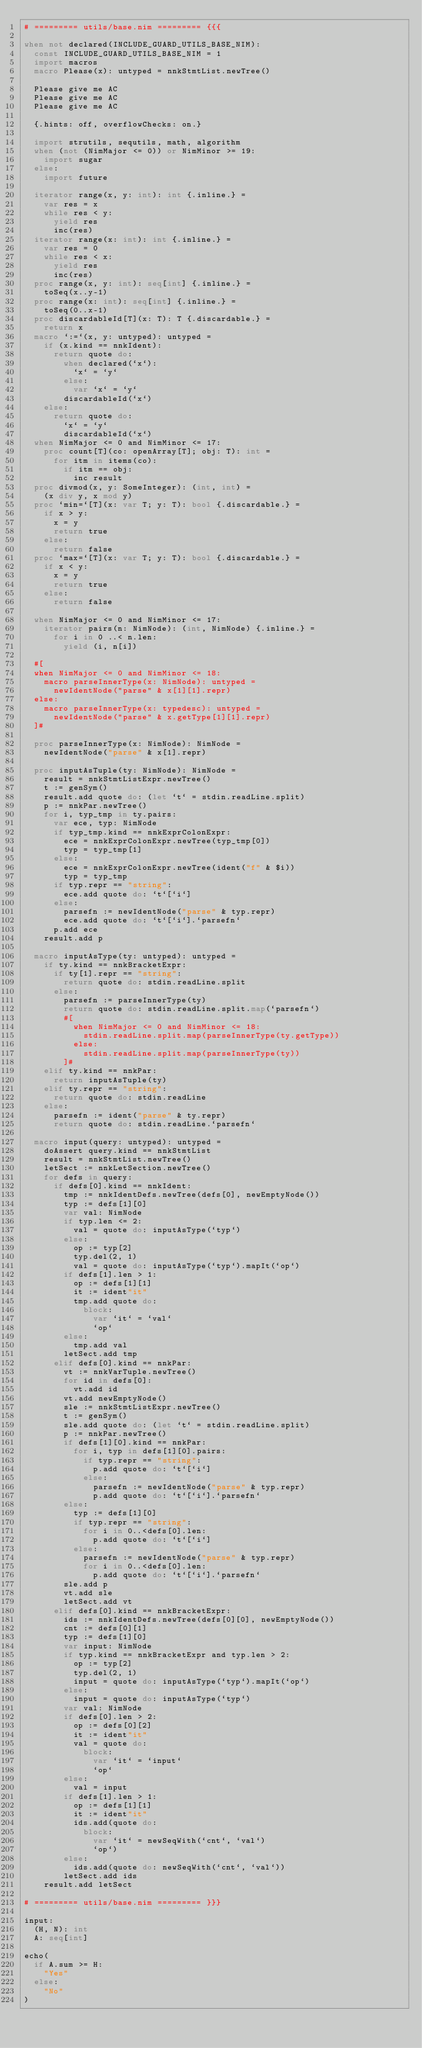Convert code to text. <code><loc_0><loc_0><loc_500><loc_500><_Nim_># ========= utils/base.nim ========= {{{

when not declared(INCLUDE_GUARD_UTILS_BASE_NIM):
  const INCLUDE_GUARD_UTILS_BASE_NIM = 1
  import macros
  macro Please(x): untyped = nnkStmtList.newTree()

  Please give me AC
  Please give me AC
  Please give me AC

  {.hints: off, overflowChecks: on.}

  import strutils, sequtils, math, algorithm
  when (not (NimMajor <= 0)) or NimMinor >= 19:
    import sugar
  else:
    import future

  iterator range(x, y: int): int {.inline.} =
    var res = x
    while res < y:
      yield res
      inc(res)
  iterator range(x: int): int {.inline.} =
    var res = 0
    while res < x:
      yield res
      inc(res)
  proc range(x, y: int): seq[int] {.inline.} =
    toSeq(x..y-1)
  proc range(x: int): seq[int] {.inline.} =
    toSeq(0..x-1)
  proc discardableId[T](x: T): T {.discardable.} =
    return x
  macro `:=`(x, y: untyped): untyped =
    if (x.kind == nnkIdent):
      return quote do:
        when declared(`x`):
          `x` = `y`
        else:
          var `x` = `y`
        discardableId(`x`)
    else:
      return quote do:
        `x` = `y`
        discardableId(`x`)
  when NimMajor <= 0 and NimMinor <= 17:
    proc count[T](co: openArray[T]; obj: T): int =
      for itm in items(co):
        if itm == obj:
          inc result
  proc divmod(x, y: SomeInteger): (int, int) =
    (x div y, x mod y)
  proc `min=`[T](x: var T; y: T): bool {.discardable.} =
    if x > y:
      x = y
      return true
    else:
      return false
  proc `max=`[T](x: var T; y: T): bool {.discardable.} =
    if x < y:
      x = y
      return true
    else:
      return false

  when NimMajor <= 0 and NimMinor <= 17:
    iterator pairs(n: NimNode): (int, NimNode) {.inline.} =
      for i in 0 ..< n.len:
        yield (i, n[i])

  #[
  when NimMajor <= 0 and NimMinor <= 18:
    macro parseInnerType(x: NimNode): untyped =
      newIdentNode("parse" & x[1][1].repr)
  else:
    macro parseInnerType(x: typedesc): untyped =
      newIdentNode("parse" & x.getType[1][1].repr)
  ]#

  proc parseInnerType(x: NimNode): NimNode =
    newIdentNode("parse" & x[1].repr)

  proc inputAsTuple(ty: NimNode): NimNode =
    result = nnkStmtListExpr.newTree()
    t := genSym()
    result.add quote do: (let `t` = stdin.readLine.split)
    p := nnkPar.newTree()
    for i, typ_tmp in ty.pairs:
      var ece, typ: NimNode
      if typ_tmp.kind == nnkExprColonExpr:
        ece = nnkExprColonExpr.newTree(typ_tmp[0])
        typ = typ_tmp[1]
      else:
        ece = nnkExprColonExpr.newTree(ident("f" & $i))
        typ = typ_tmp
      if typ.repr == "string":
        ece.add quote do: `t`[`i`]
      else:
        parsefn := newIdentNode("parse" & typ.repr)
        ece.add quote do: `t`[`i`].`parsefn`
      p.add ece
    result.add p

  macro inputAsType(ty: untyped): untyped =
    if ty.kind == nnkBracketExpr:
      if ty[1].repr == "string":
        return quote do: stdin.readLine.split
      else:
        parsefn := parseInnerType(ty)
        return quote do: stdin.readLine.split.map(`parsefn`)
        #[
          when NimMajor <= 0 and NimMinor <= 18:
            stdin.readLine.split.map(parseInnerType(ty.getType))
          else:
            stdin.readLine.split.map(parseInnerType(ty))
        ]#
    elif ty.kind == nnkPar:
      return inputAsTuple(ty)
    elif ty.repr == "string":
      return quote do: stdin.readLine
    else:
      parsefn := ident("parse" & ty.repr)
      return quote do: stdin.readLine.`parsefn`

  macro input(query: untyped): untyped =
    doAssert query.kind == nnkStmtList
    result = nnkStmtList.newTree()
    letSect := nnkLetSection.newTree()
    for defs in query:
      if defs[0].kind == nnkIdent:
        tmp := nnkIdentDefs.newTree(defs[0], newEmptyNode())
        typ := defs[1][0]
        var val: NimNode
        if typ.len <= 2:
          val = quote do: inputAsType(`typ`)
        else:
          op := typ[2]
          typ.del(2, 1)
          val = quote do: inputAsType(`typ`).mapIt(`op`)
        if defs[1].len > 1:
          op := defs[1][1]
          it := ident"it"
          tmp.add quote do:
            block:
              var `it` = `val`
              `op`
        else:
          tmp.add val
        letSect.add tmp
      elif defs[0].kind == nnkPar:
        vt := nnkVarTuple.newTree()
        for id in defs[0]:
          vt.add id
        vt.add newEmptyNode()
        sle := nnkStmtListExpr.newTree()
        t := genSym()
        sle.add quote do: (let `t` = stdin.readLine.split)
        p := nnkPar.newTree()
        if defs[1][0].kind == nnkPar:
          for i, typ in defs[1][0].pairs:
            if typ.repr == "string":
              p.add quote do: `t`[`i`]
            else:
              parsefn := newIdentNode("parse" & typ.repr)
              p.add quote do: `t`[`i`].`parsefn`
        else:
          typ := defs[1][0]
          if typ.repr == "string":
            for i in 0..<defs[0].len:
              p.add quote do: `t`[`i`]
          else:
            parsefn := newIdentNode("parse" & typ.repr)
            for i in 0..<defs[0].len:
              p.add quote do: `t`[`i`].`parsefn`
        sle.add p
        vt.add sle
        letSect.add vt
      elif defs[0].kind == nnkBracketExpr:
        ids := nnkIdentDefs.newTree(defs[0][0], newEmptyNode())
        cnt := defs[0][1]
        typ := defs[1][0]
        var input: NimNode
        if typ.kind == nnkBracketExpr and typ.len > 2:
          op := typ[2]
          typ.del(2, 1)
          input = quote do: inputAsType(`typ`).mapIt(`op`)
        else:
          input = quote do: inputAsType(`typ`)
        var val: NimNode
        if defs[0].len > 2:
          op := defs[0][2]
          it := ident"it"
          val = quote do:
            block:
              var `it` = `input`
              `op`
        else:
          val = input
        if defs[1].len > 1:
          op := defs[1][1]
          it := ident"it"
          ids.add(quote do:
            block:
              var `it` = newSeqWith(`cnt`, `val`)
              `op`)
        else:
          ids.add(quote do: newSeqWith(`cnt`, `val`))
        letSect.add ids
    result.add letSect

# ========= utils/base.nim ========= }}}

input:
  (H, N): int
  A: seq[int]

echo(
  if A.sum >= H:
    "Yes"
  else:
    "No"
)
</code> 